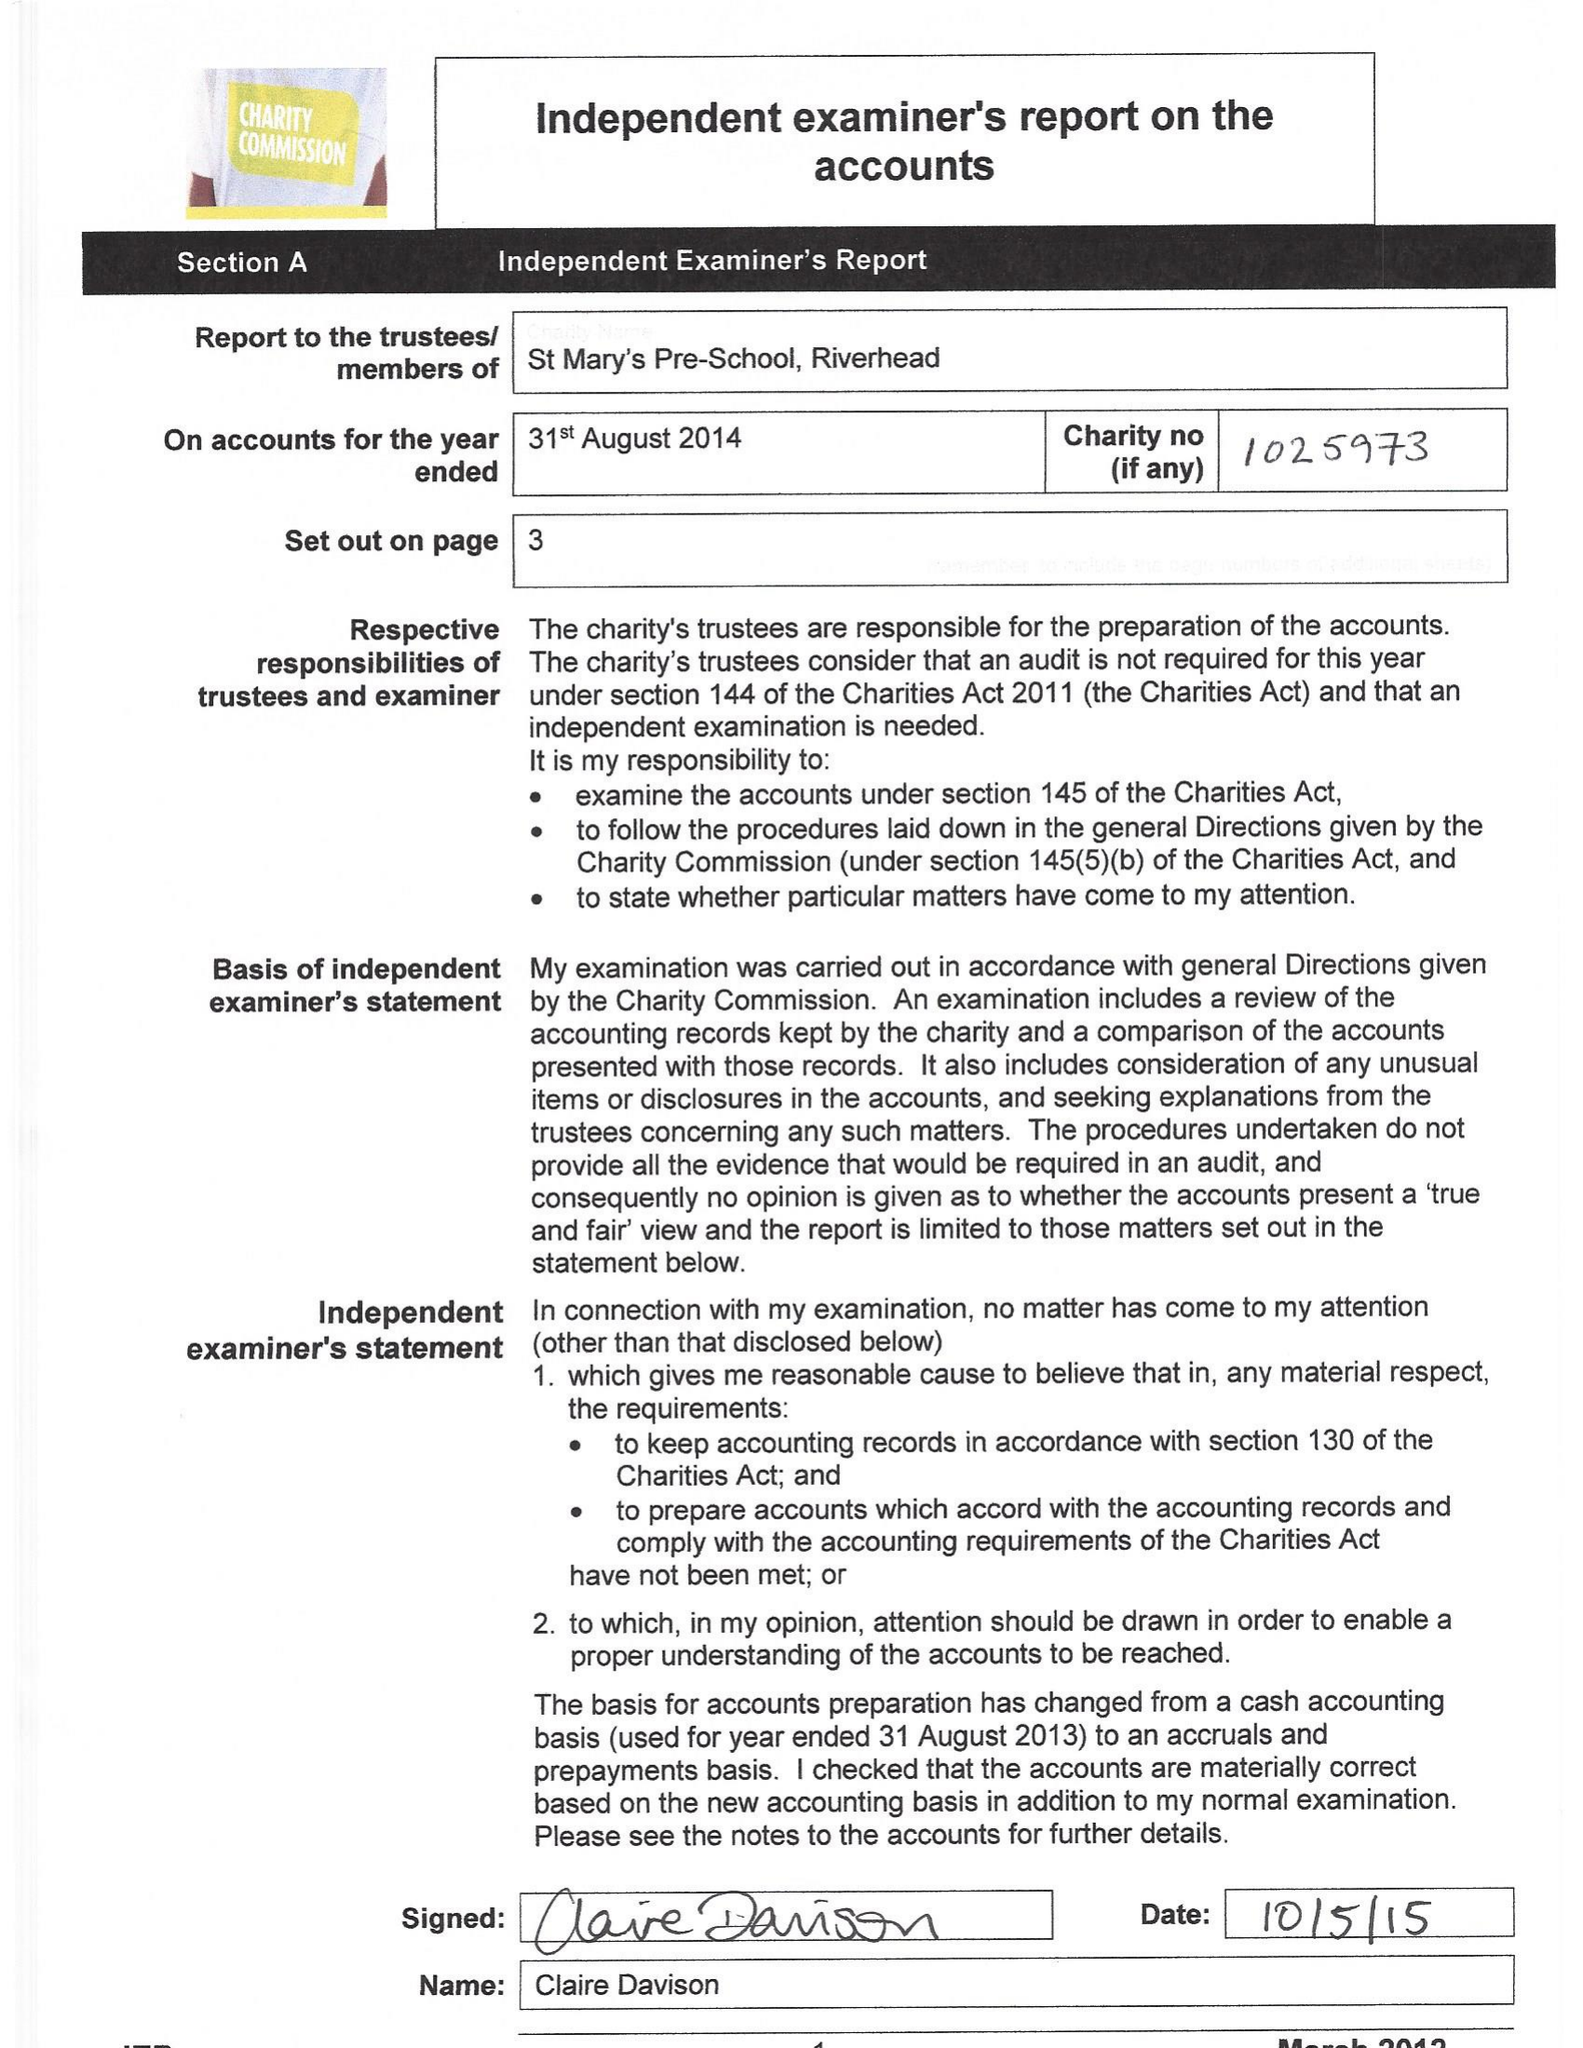What is the value for the income_annually_in_british_pounds?
Answer the question using a single word or phrase. 62267.37 